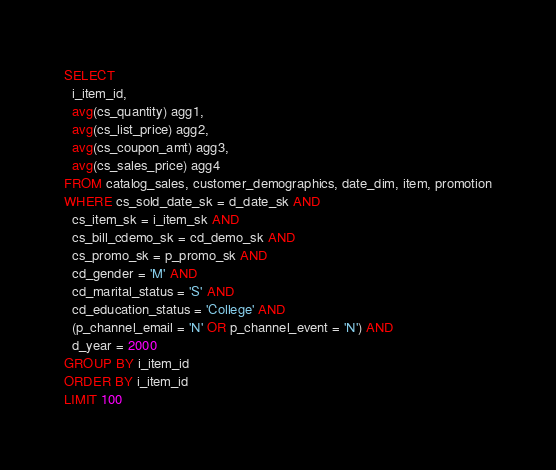Convert code to text. <code><loc_0><loc_0><loc_500><loc_500><_SQL_>SELECT
  i_item_id,
  avg(cs_quantity) agg1,
  avg(cs_list_price) agg2,
  avg(cs_coupon_amt) agg3,
  avg(cs_sales_price) agg4
FROM catalog_sales, customer_demographics, date_dim, item, promotion
WHERE cs_sold_date_sk = d_date_sk AND
  cs_item_sk = i_item_sk AND
  cs_bill_cdemo_sk = cd_demo_sk AND
  cs_promo_sk = p_promo_sk AND
  cd_gender = 'M' AND
  cd_marital_status = 'S' AND
  cd_education_status = 'College' AND
  (p_channel_email = 'N' OR p_channel_event = 'N') AND
  d_year = 2000
GROUP BY i_item_id
ORDER BY i_item_id
LIMIT 100
</code> 